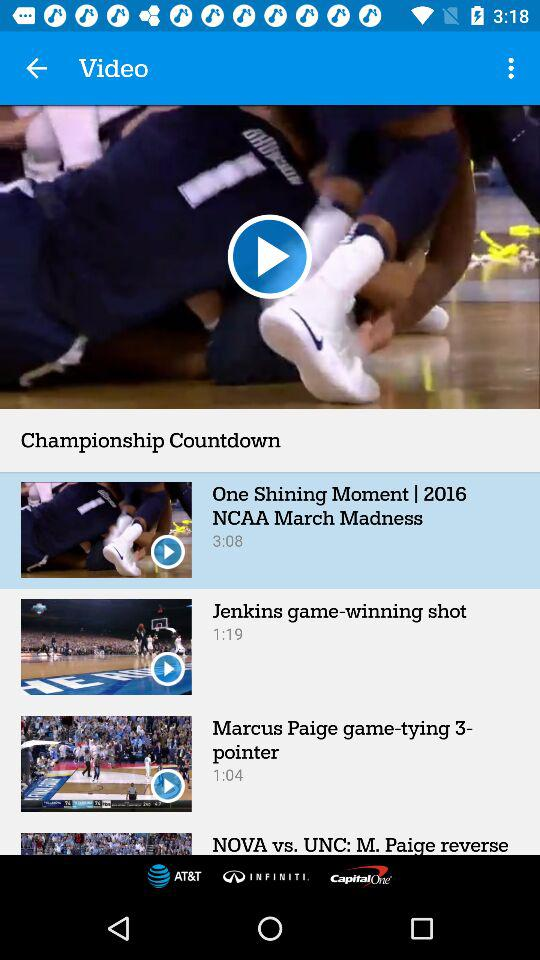What is the duration of one shining moment? The duration is 3:08. 